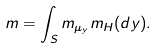Convert formula to latex. <formula><loc_0><loc_0><loc_500><loc_500>m = \int _ { S } m _ { \mu _ { y } } m _ { H } ( d y ) .</formula> 